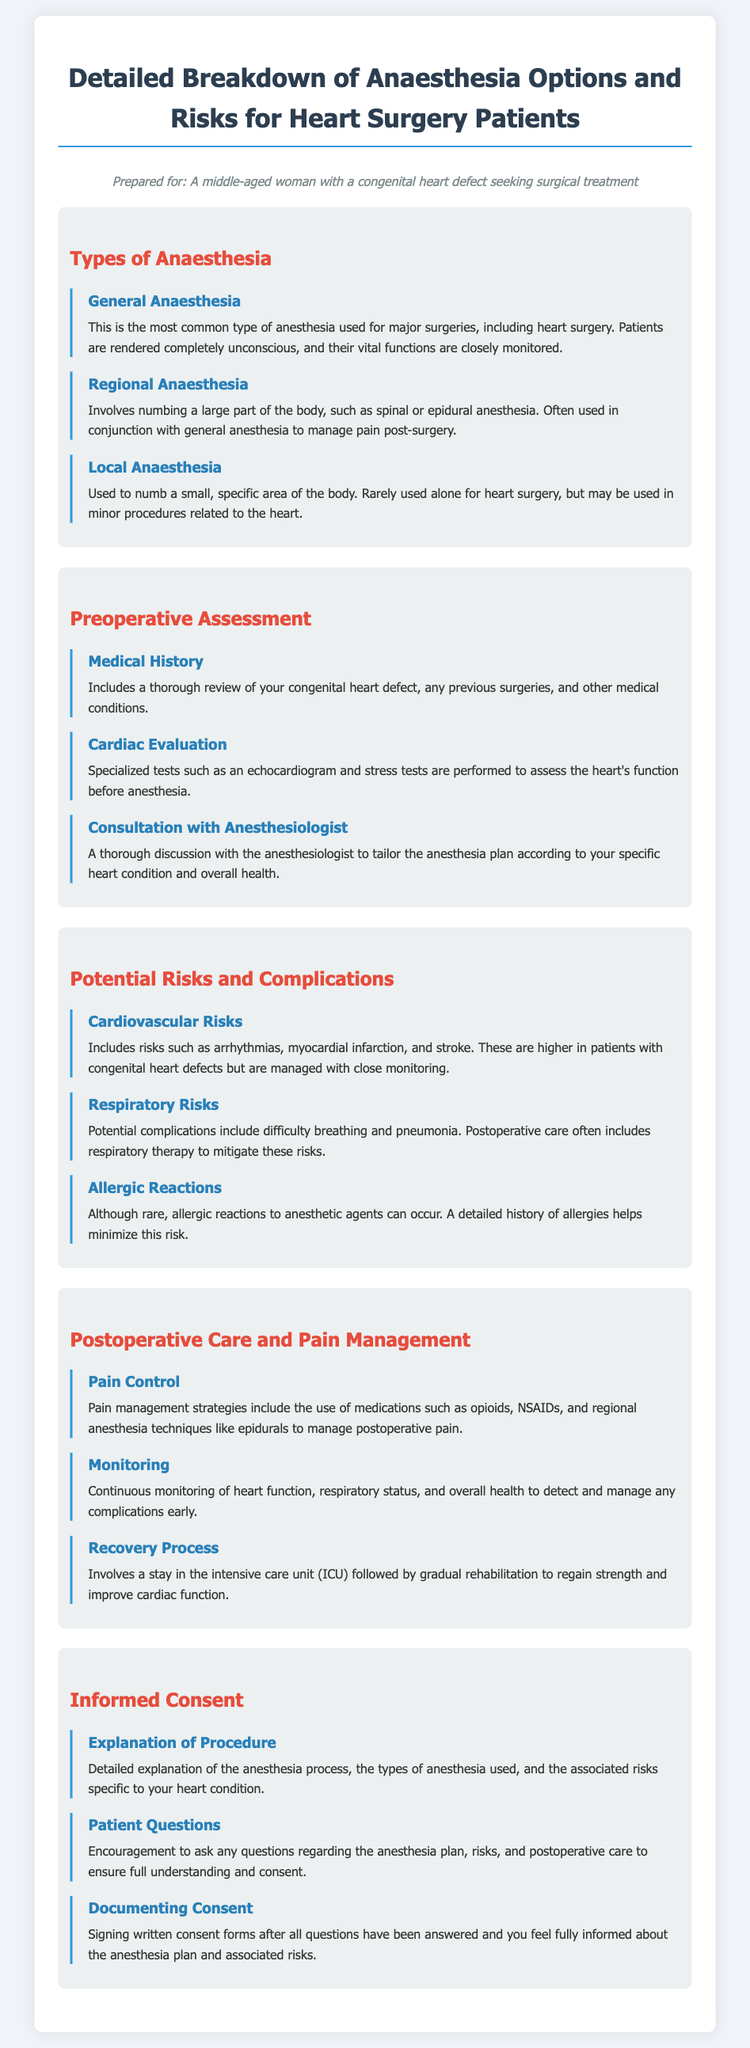what is the most common type of anesthesia used for major surgeries? The most common type of anesthesia used for major surgeries, including heart surgery, is General Anaesthesia.
Answer: General Anaesthesia what are the specialized tests performed to assess the heart's function before anesthesia? The specialized tests performed to assess the heart's function before anesthesia include an echocardiogram and stress tests.
Answer: echocardiogram and stress tests which anesthesia option involves numbing a large part of the body? The anesthesia option that involves numbing a large part of the body is Regional Anaesthesia.
Answer: Regional Anaesthesia what is a potential cardiovascular risk during heart surgery? A potential cardiovascular risk during heart surgery includes arrhythmias.
Answer: arrhythmias how is postoperative pain managed? Postoperative pain is managed through the use of medications such as opioids, NSAIDs, and regional anesthesia techniques like epidurals.
Answer: medications such as opioids, NSAIDs, and regional anesthesia techniques like epidurals what should be documented after all questions have been answered regarding anesthesia? After all questions have been answered regarding anesthesia, written consent forms should be signed.
Answer: written consent forms what is the purpose of consulting with an anesthesiologist before surgery? The purpose of consulting with an anesthesiologist before surgery is to tailor the anesthesia plan according to the specific heart condition and overall health.
Answer: tailor the anesthesia plan what type of anesthesia is rarely used alone for heart surgery? The type of anesthesia that is rarely used alone for heart surgery is Local Anaesthesia.
Answer: Local Anaesthesia what is included in the postoperative monitoring process? The postoperative monitoring process includes continuous monitoring of heart function, respiratory status, and overall health.
Answer: continuous monitoring of heart function, respiratory status, and overall health 